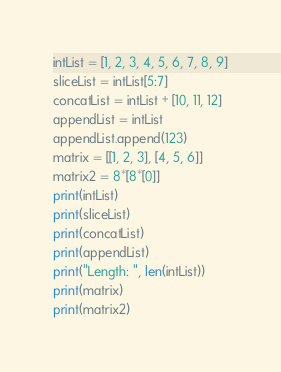<code> <loc_0><loc_0><loc_500><loc_500><_Python_>intList = [1, 2, 3, 4, 5, 6, 7, 8, 9]
sliceList = intList[5:7]
concatList = intList + [10, 11, 12]
appendList = intList
appendList.append(123)
matrix = [[1, 2, 3], [4, 5, 6]]
matrix2 = 8*[8*[0]]
print(intList)
print(sliceList)
print(concatList)
print(appendList)
print("Length: ", len(intList))
print(matrix)
print(matrix2)</code> 